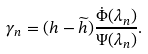<formula> <loc_0><loc_0><loc_500><loc_500>\gamma _ { n } = ( h - \widetilde { h } ) \frac { \dot { \Phi } ( \lambda _ { n } ) } { \Psi ( \lambda _ { n } ) } .</formula> 